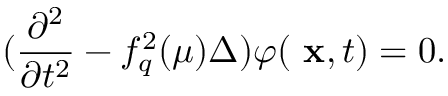<formula> <loc_0><loc_0><loc_500><loc_500>( \frac { \partial ^ { 2 } } { \partial t ^ { 2 } } - f _ { q } ^ { 2 } ( \mu ) \Delta ) \varphi ( x , t ) = 0 .</formula> 